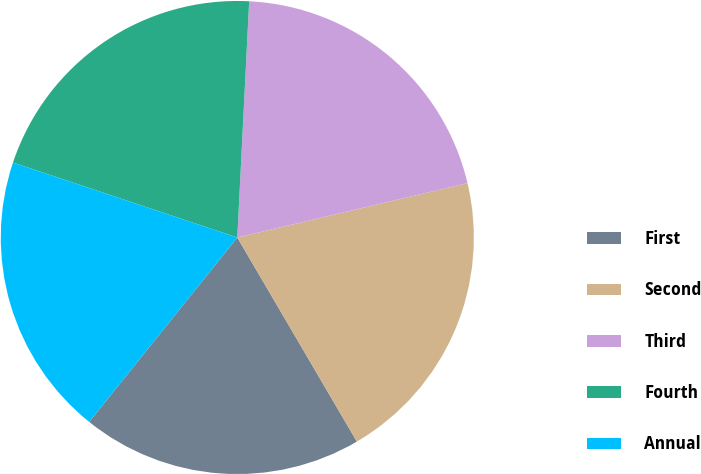Convert chart to OTSL. <chart><loc_0><loc_0><loc_500><loc_500><pie_chart><fcel>First<fcel>Second<fcel>Third<fcel>Fourth<fcel>Annual<nl><fcel>19.21%<fcel>20.26%<fcel>20.51%<fcel>20.67%<fcel>19.36%<nl></chart> 